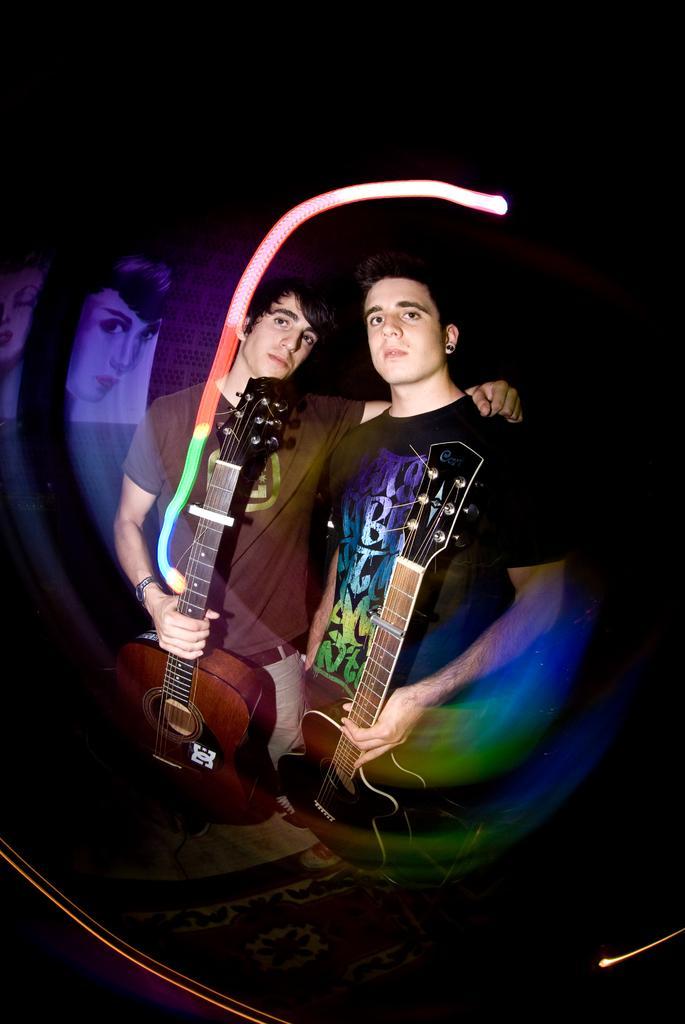Please provide a concise description of this image. This picture shows two men standing holding a guitar in their hands 